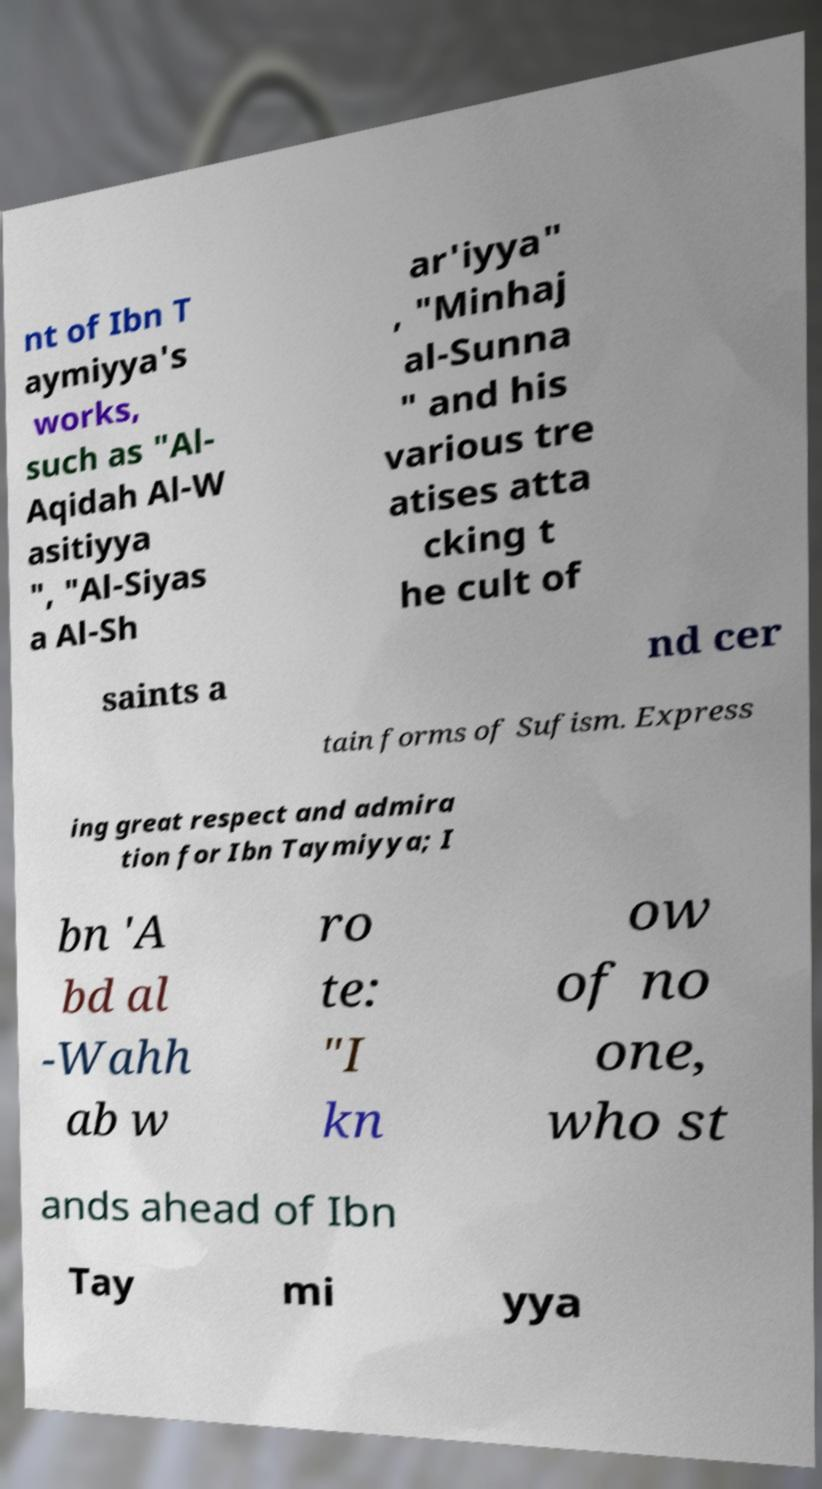For documentation purposes, I need the text within this image transcribed. Could you provide that? nt of Ibn T aymiyya's works, such as "Al- Aqidah Al-W asitiyya ", "Al-Siyas a Al-Sh ar'iyya" , "Minhaj al-Sunna " and his various tre atises atta cking t he cult of saints a nd cer tain forms of Sufism. Express ing great respect and admira tion for Ibn Taymiyya; I bn 'A bd al -Wahh ab w ro te: "I kn ow of no one, who st ands ahead of Ibn Tay mi yya 